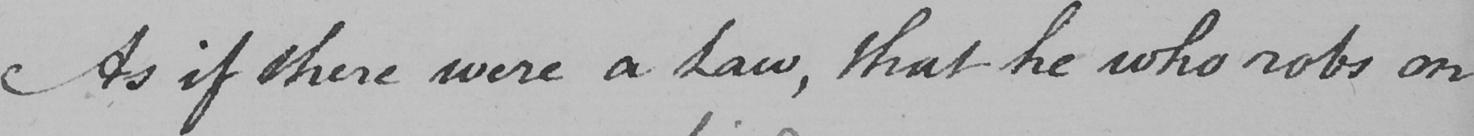What does this handwritten line say? As if there were a Law , that he who robs on 